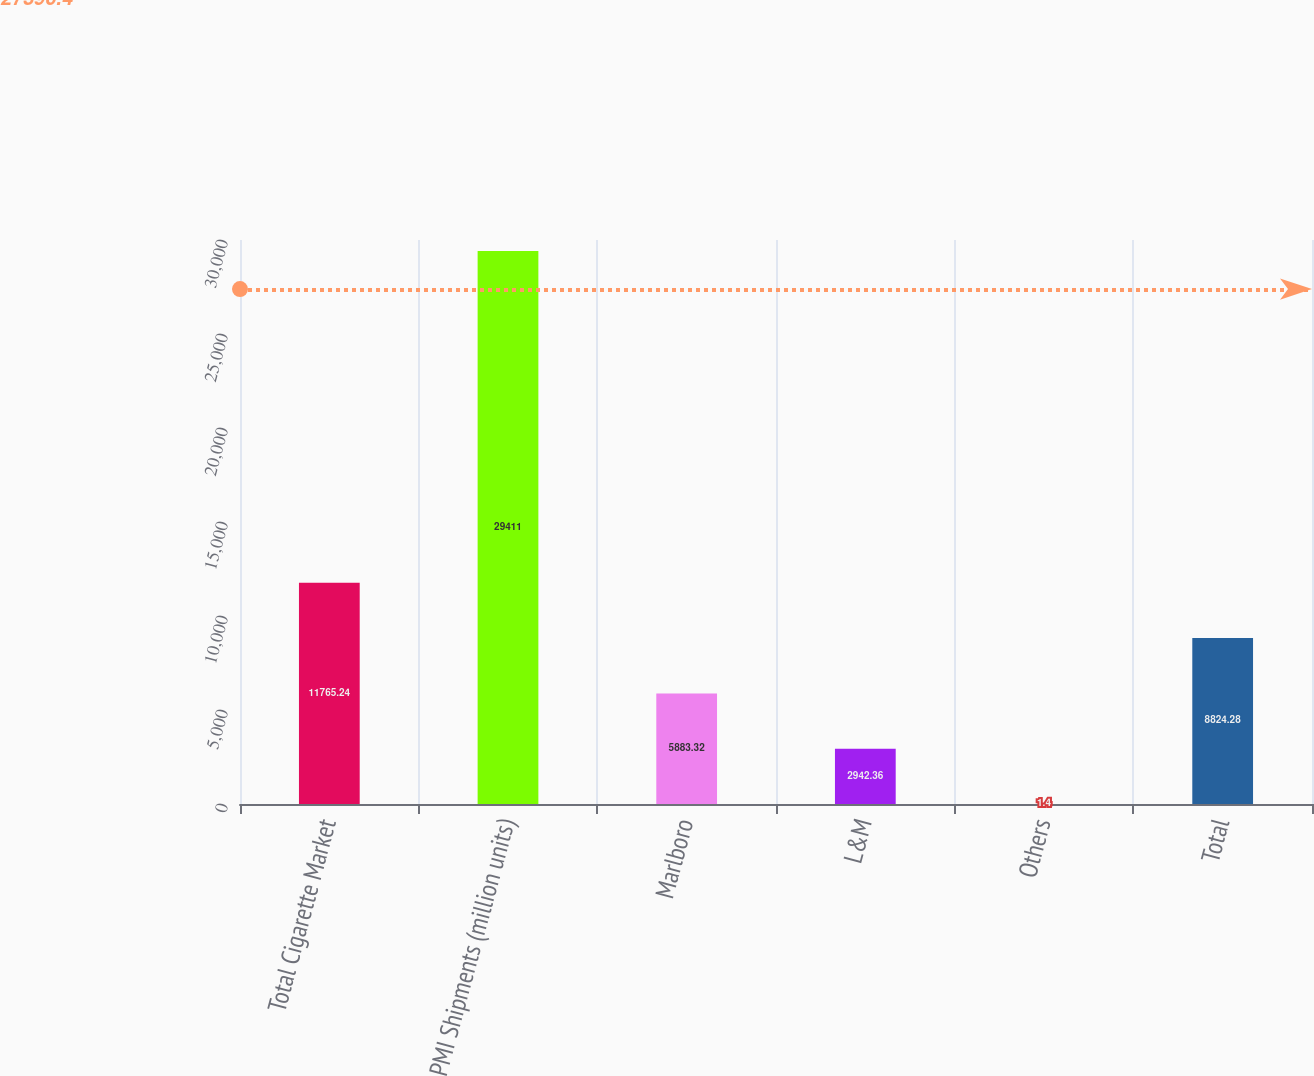Convert chart. <chart><loc_0><loc_0><loc_500><loc_500><bar_chart><fcel>Total Cigarette Market<fcel>PMI Shipments (million units)<fcel>Marlboro<fcel>L&M<fcel>Others<fcel>Total<nl><fcel>11765.2<fcel>29411<fcel>5883.32<fcel>2942.36<fcel>1.4<fcel>8824.28<nl></chart> 